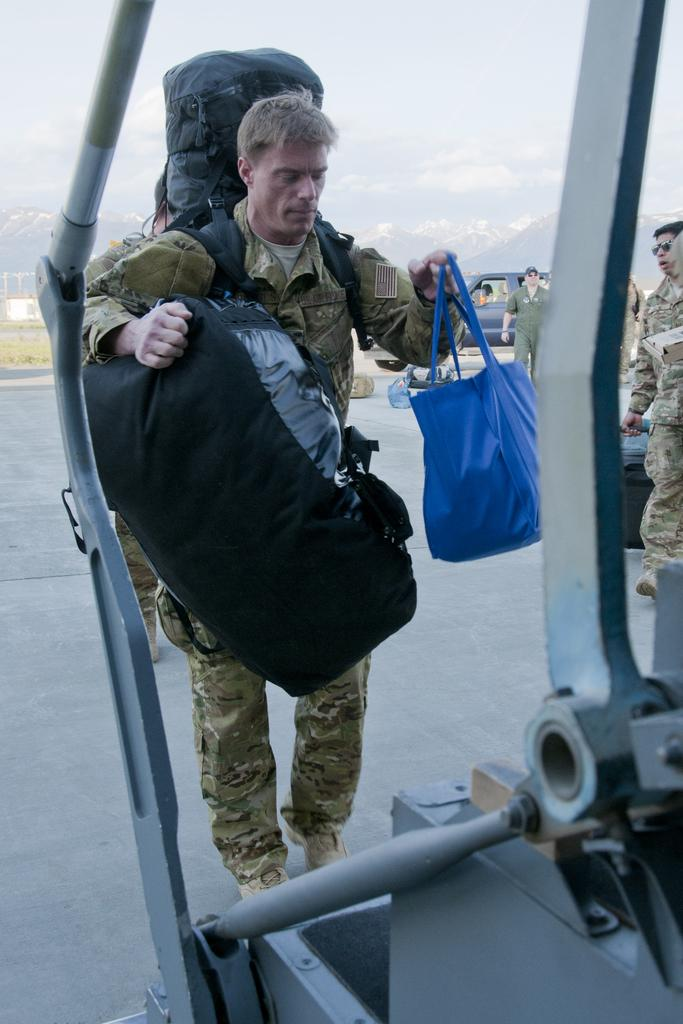Who is the main subject in the image? There is a man in the middle of the image. What is the man holding? The man is holding bags. What architectural feature can be seen at the bottom of the image? There is a staircase at the bottom of the image. What can be seen in the background of the image? There are people, a vehicle, hills, grass, a road, and the sky visible in the background of the image. What type of sponge can be seen in the image? There is no sponge present in the image. Are there any bears visible in the image? No, there are no bears visible in the image. 